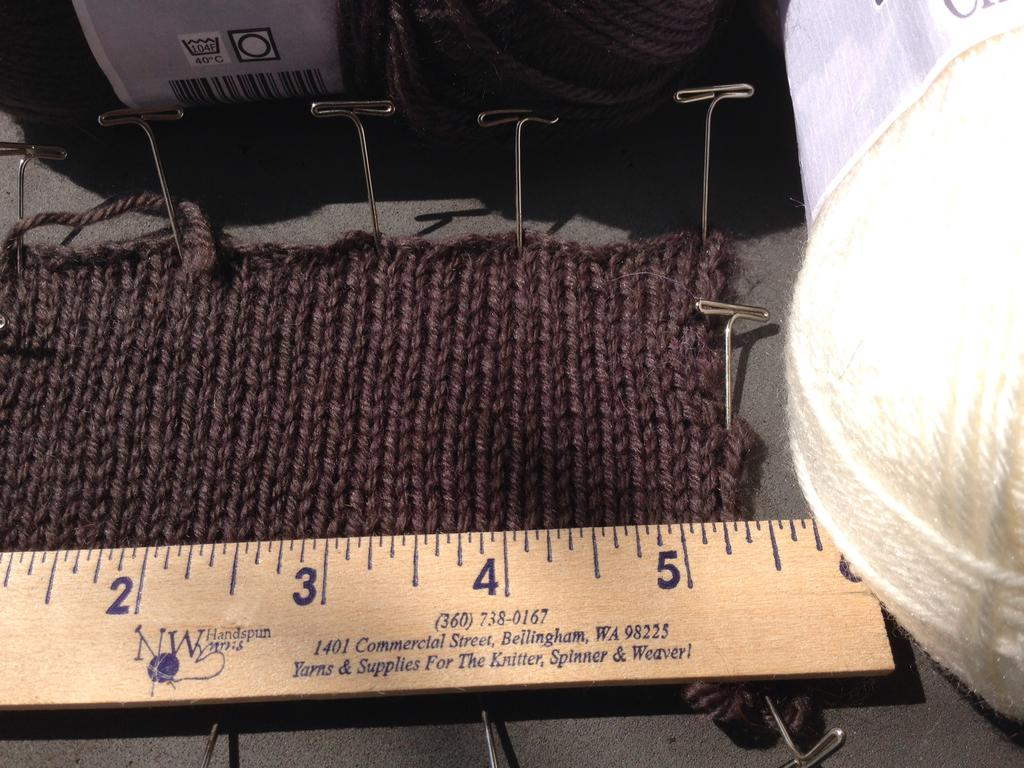<image>
Share a concise interpretation of the image provided. A knitted scarf is next to a measuring stick that says NW Handspun Yarns. 